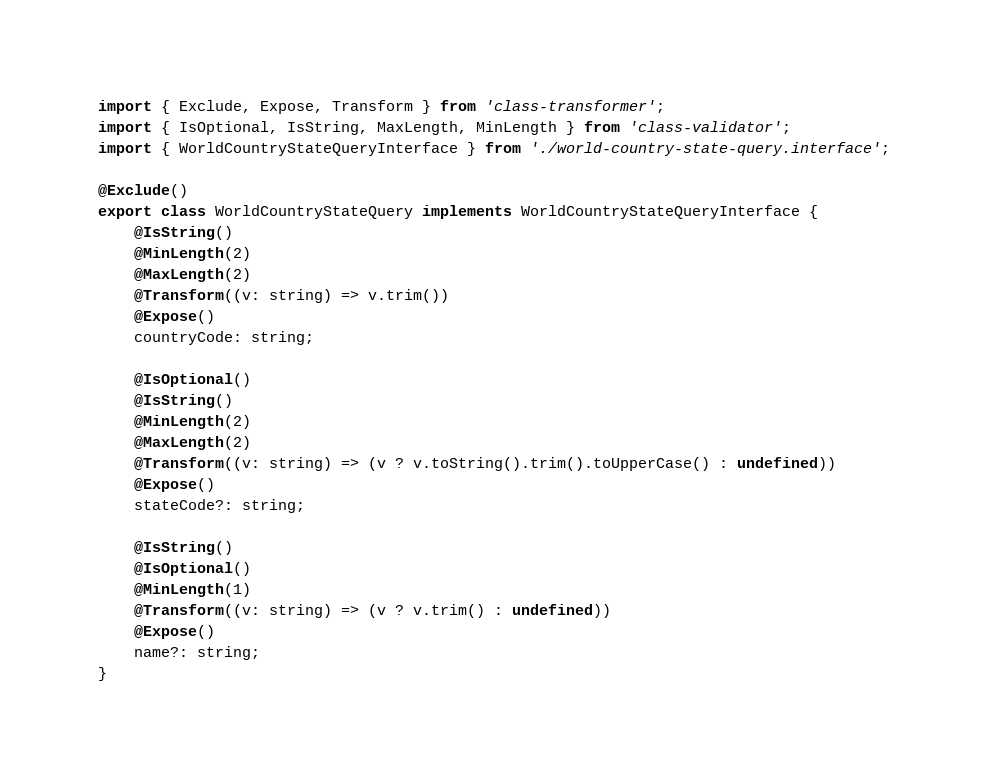Convert code to text. <code><loc_0><loc_0><loc_500><loc_500><_TypeScript_>import { Exclude, Expose, Transform } from 'class-transformer';
import { IsOptional, IsString, MaxLength, MinLength } from 'class-validator';
import { WorldCountryStateQueryInterface } from './world-country-state-query.interface';

@Exclude()
export class WorldCountryStateQuery implements WorldCountryStateQueryInterface {
    @IsString()
    @MinLength(2)
    @MaxLength(2)
    @Transform((v: string) => v.trim())
    @Expose()
    countryCode: string;

    @IsOptional()
    @IsString()
    @MinLength(2)
    @MaxLength(2)
    @Transform((v: string) => (v ? v.toString().trim().toUpperCase() : undefined))
    @Expose()
    stateCode?: string;

    @IsString()
    @IsOptional()
    @MinLength(1)
    @Transform((v: string) => (v ? v.trim() : undefined))
    @Expose()
    name?: string;
}
</code> 